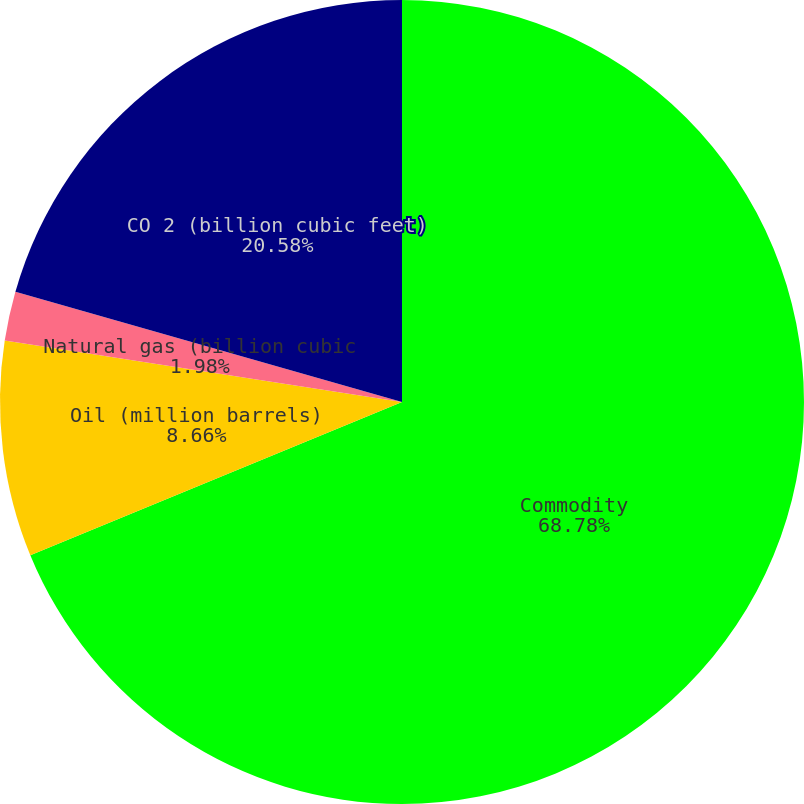Convert chart. <chart><loc_0><loc_0><loc_500><loc_500><pie_chart><fcel>Commodity<fcel>Oil (million barrels)<fcel>Natural gas (billion cubic<fcel>CO 2 (billion cubic feet)<nl><fcel>68.78%<fcel>8.66%<fcel>1.98%<fcel>20.58%<nl></chart> 